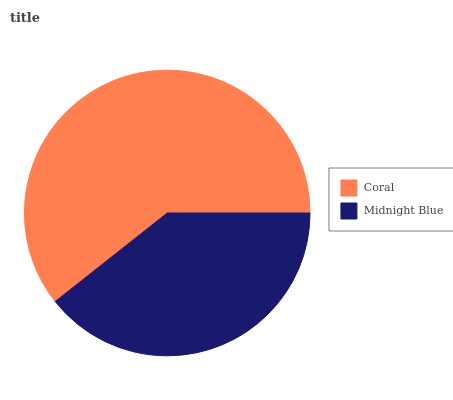Is Midnight Blue the minimum?
Answer yes or no. Yes. Is Coral the maximum?
Answer yes or no. Yes. Is Midnight Blue the maximum?
Answer yes or no. No. Is Coral greater than Midnight Blue?
Answer yes or no. Yes. Is Midnight Blue less than Coral?
Answer yes or no. Yes. Is Midnight Blue greater than Coral?
Answer yes or no. No. Is Coral less than Midnight Blue?
Answer yes or no. No. Is Coral the high median?
Answer yes or no. Yes. Is Midnight Blue the low median?
Answer yes or no. Yes. Is Midnight Blue the high median?
Answer yes or no. No. Is Coral the low median?
Answer yes or no. No. 